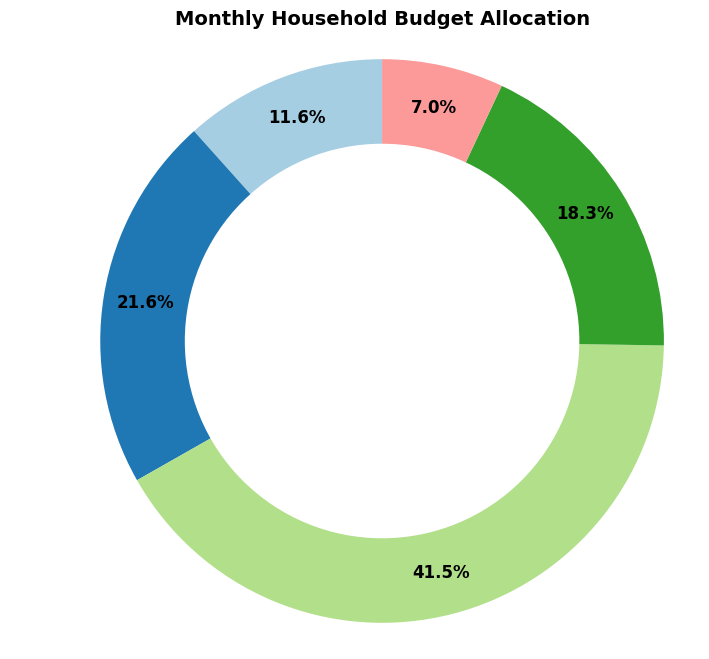What percentage of the budget is allocated to Rent? The pie chart's section labeled 'Rent' shows the percentage allocated to rent. Comparing the wedges' sizes visually indicates that Rent takes up a significant portion of the budget. By referring to the label next to this section, we can read the specific percentage.
Answer: [Percentage displayed for Rent in pie chart] What's the total percentage allocated to Savings and Groceries combined? Locate the wedges for 'Savings' and 'Groceries' on the pie chart. Add their respective percentages from the labels provided.
Answer: [Savings %] + [Groceries %] = [Total %] Which category has the smallest allocation in the budget? Examine the pie chart and identify which wedge is the smallest. This wedge represents the category with the smallest allocation.
Answer: [Smallest category by wedge size] Is more budget allocated to Entertainment or Utilities? Compare the size of the wedges labeled 'Entertainment' and 'Utilities.' Identify which one is larger to determine which category has a greater allocation.
Answer: [Category with the larger wedge] What is the difference in percentage points between the amount spent on Rent and the amount spent on Entertainment? Find the percentage for Rent and the percentage for Entertainment by referencing their respective labels on the pie chart. Subtract the Entertainment percentage from the Rent percentage to get the difference.
Answer: [Rent %] - [Entertainment %] = [Difference in percentage points] What visual feature denotes the savings category? Look for the visual attributes such as color or position on the pie chart for the savings category, identified by the 'Savings' label.
Answer: [Color or feature denoting Savings] What is the approximate percentage allocated to Utilities? Refer to the pie chart section labeled 'Utilities' to see the approximate percentage given next to it.
Answer: [Approximate percentage for Utilities] How many categories have a budget allocation of over 20%? Examine the chart and count the number of wedges with labels indicating a percentage greater than 20%.
Answer: [Number of categories over 20%] Does Groceries or Savings represent a larger portion of the budget? Compare the wedges for 'Groceries' and 'Savings' in the chart. Determine which one is larger visibly and confirm by percentages.
Answer: [Larger category by wedge size] Which category takes up more than a quarter of the budget? Look for the wedge that has a label indicating more than 25% allocation. Visually confirm it takes up more than a quarter of the pie chart.
Answer: [Category over 25%] 